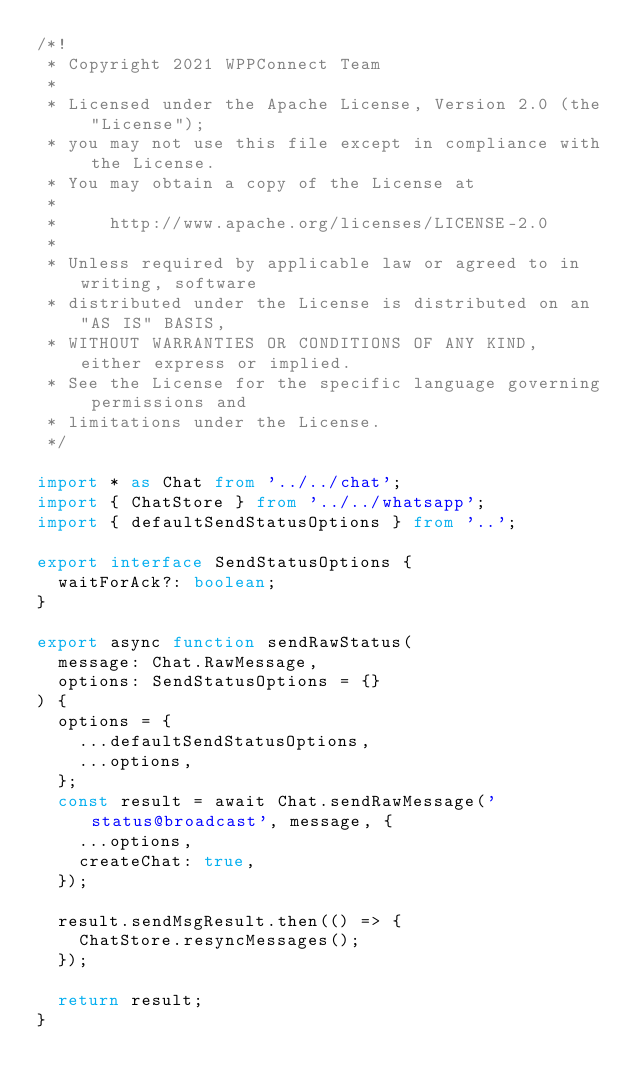<code> <loc_0><loc_0><loc_500><loc_500><_TypeScript_>/*!
 * Copyright 2021 WPPConnect Team
 *
 * Licensed under the Apache License, Version 2.0 (the "License");
 * you may not use this file except in compliance with the License.
 * You may obtain a copy of the License at
 *
 *     http://www.apache.org/licenses/LICENSE-2.0
 *
 * Unless required by applicable law or agreed to in writing, software
 * distributed under the License is distributed on an "AS IS" BASIS,
 * WITHOUT WARRANTIES OR CONDITIONS OF ANY KIND, either express or implied.
 * See the License for the specific language governing permissions and
 * limitations under the License.
 */

import * as Chat from '../../chat';
import { ChatStore } from '../../whatsapp';
import { defaultSendStatusOptions } from '..';

export interface SendStatusOptions {
  waitForAck?: boolean;
}

export async function sendRawStatus(
  message: Chat.RawMessage,
  options: SendStatusOptions = {}
) {
  options = {
    ...defaultSendStatusOptions,
    ...options,
  };
  const result = await Chat.sendRawMessage('status@broadcast', message, {
    ...options,
    createChat: true,
  });

  result.sendMsgResult.then(() => {
    ChatStore.resyncMessages();
  });

  return result;
}
</code> 